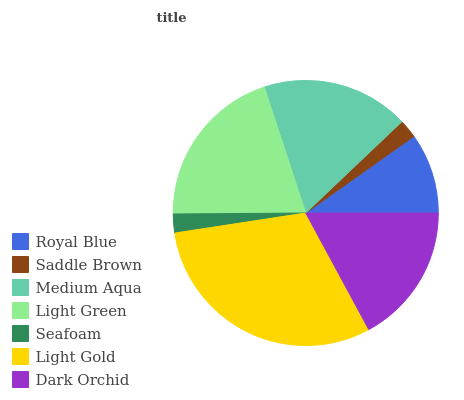Is Saddle Brown the minimum?
Answer yes or no. Yes. Is Light Gold the maximum?
Answer yes or no. Yes. Is Medium Aqua the minimum?
Answer yes or no. No. Is Medium Aqua the maximum?
Answer yes or no. No. Is Medium Aqua greater than Saddle Brown?
Answer yes or no. Yes. Is Saddle Brown less than Medium Aqua?
Answer yes or no. Yes. Is Saddle Brown greater than Medium Aqua?
Answer yes or no. No. Is Medium Aqua less than Saddle Brown?
Answer yes or no. No. Is Dark Orchid the high median?
Answer yes or no. Yes. Is Dark Orchid the low median?
Answer yes or no. Yes. Is Saddle Brown the high median?
Answer yes or no. No. Is Saddle Brown the low median?
Answer yes or no. No. 